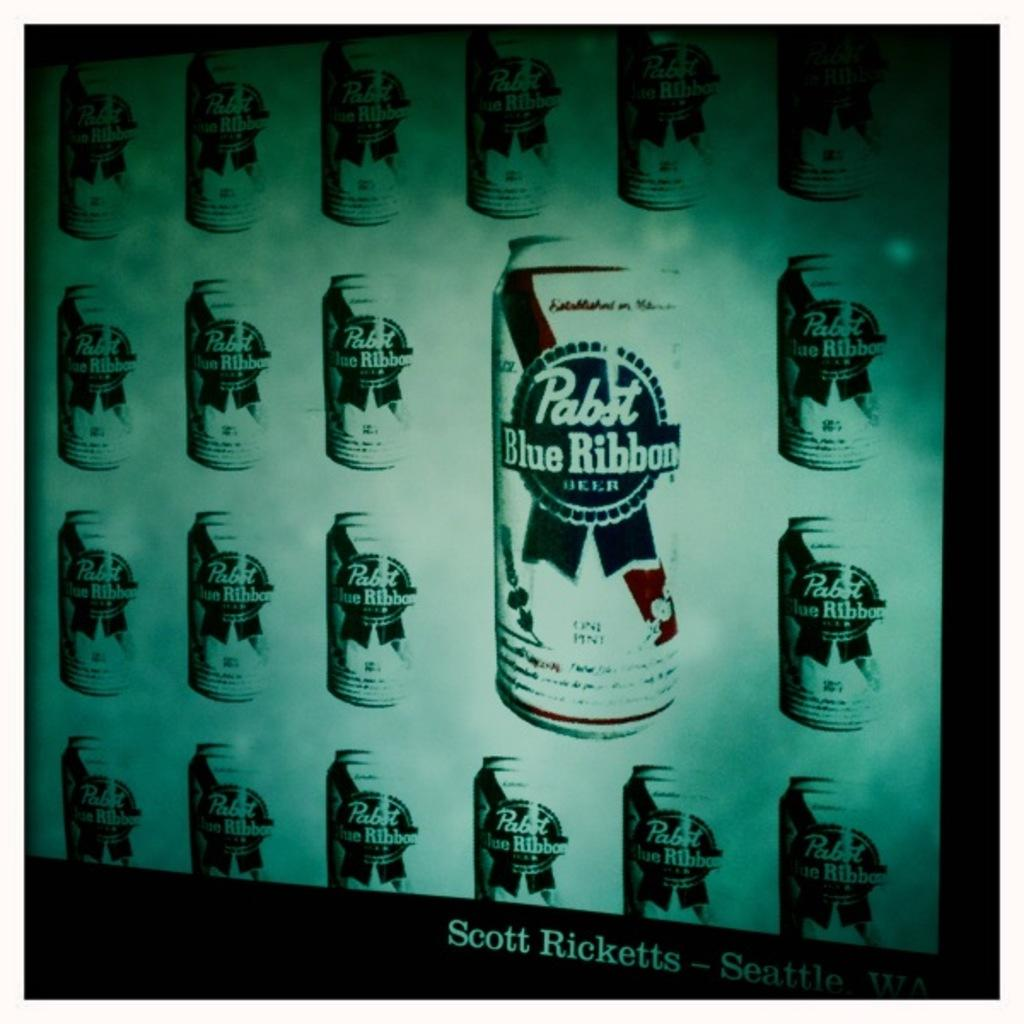Provide a one-sentence caption for the provided image. A series of Pabst Blue Ribbon cans are displayed on a wall. 